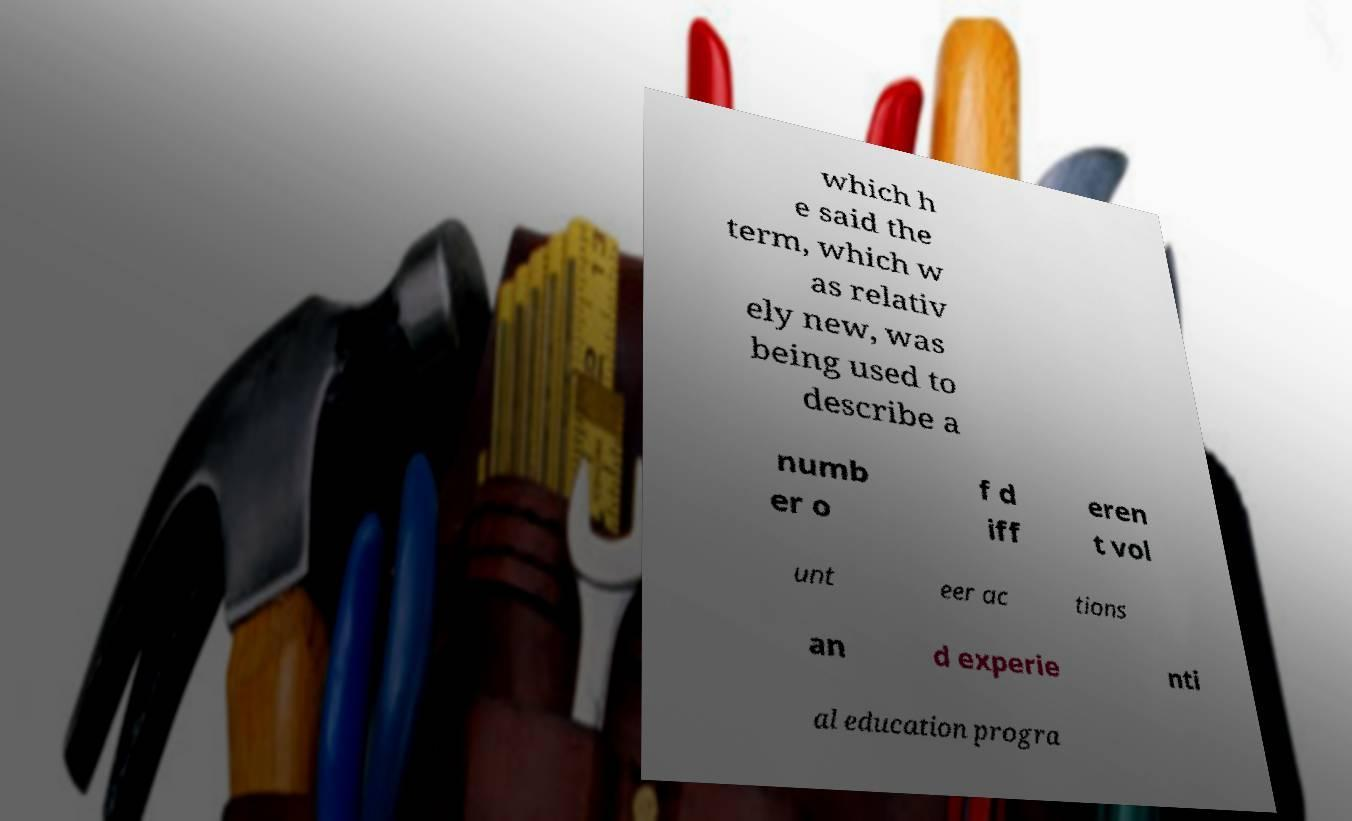Can you accurately transcribe the text from the provided image for me? which h e said the term, which w as relativ ely new, was being used to describe a numb er o f d iff eren t vol unt eer ac tions an d experie nti al education progra 